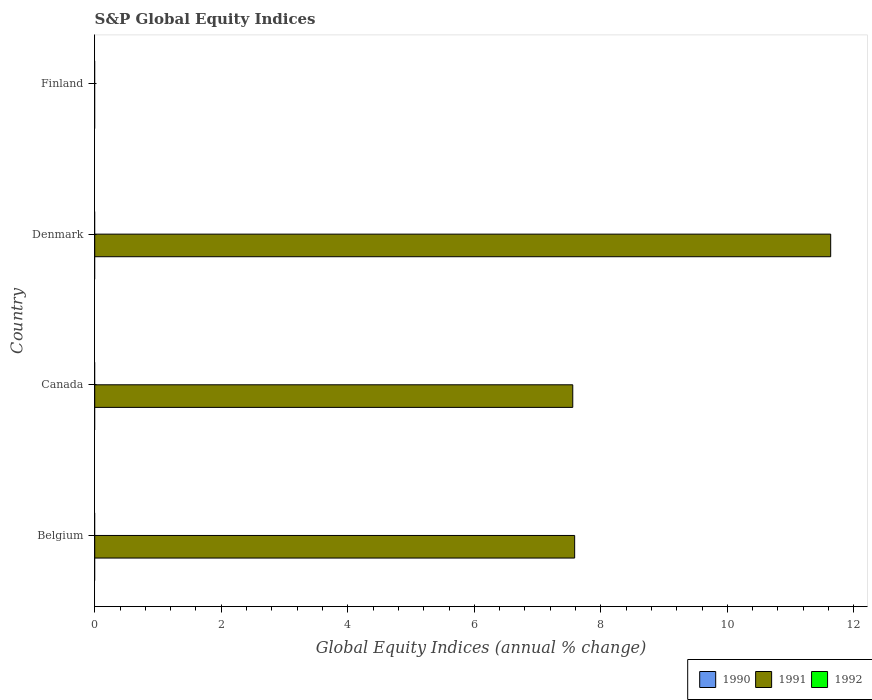How many bars are there on the 2nd tick from the top?
Keep it short and to the point. 1. What is the global equity indices in 1991 in Denmark?
Your response must be concise. 11.63. Across all countries, what is the maximum global equity indices in 1991?
Ensure brevity in your answer.  11.63. Across all countries, what is the minimum global equity indices in 1990?
Provide a short and direct response. 0. In which country was the global equity indices in 1991 maximum?
Provide a short and direct response. Denmark. What is the total global equity indices in 1991 in the graph?
Give a very brief answer. 26.78. What is the average global equity indices in 1992 per country?
Make the answer very short. 0. In how many countries, is the global equity indices in 1991 greater than 8 %?
Your response must be concise. 1. What is the ratio of the global equity indices in 1991 in Canada to that in Denmark?
Give a very brief answer. 0.65. What is the difference between the highest and the second highest global equity indices in 1991?
Offer a terse response. 4.05. What is the difference between the highest and the lowest global equity indices in 1991?
Offer a very short reply. 11.63. Is it the case that in every country, the sum of the global equity indices in 1992 and global equity indices in 1991 is greater than the global equity indices in 1990?
Your answer should be compact. No. How many bars are there?
Provide a succinct answer. 3. How many countries are there in the graph?
Offer a terse response. 4. What is the difference between two consecutive major ticks on the X-axis?
Your answer should be very brief. 2. Does the graph contain any zero values?
Provide a succinct answer. Yes. Does the graph contain grids?
Make the answer very short. No. Where does the legend appear in the graph?
Your response must be concise. Bottom right. How are the legend labels stacked?
Your response must be concise. Horizontal. What is the title of the graph?
Provide a succinct answer. S&P Global Equity Indices. Does "1973" appear as one of the legend labels in the graph?
Your answer should be compact. No. What is the label or title of the X-axis?
Make the answer very short. Global Equity Indices (annual % change). What is the Global Equity Indices (annual % change) in 1990 in Belgium?
Offer a very short reply. 0. What is the Global Equity Indices (annual % change) of 1991 in Belgium?
Provide a short and direct response. 7.59. What is the Global Equity Indices (annual % change) in 1990 in Canada?
Your answer should be compact. 0. What is the Global Equity Indices (annual % change) in 1991 in Canada?
Offer a very short reply. 7.56. What is the Global Equity Indices (annual % change) in 1991 in Denmark?
Your answer should be very brief. 11.63. What is the Global Equity Indices (annual % change) in 1990 in Finland?
Ensure brevity in your answer.  0. Across all countries, what is the maximum Global Equity Indices (annual % change) in 1991?
Provide a short and direct response. 11.63. Across all countries, what is the minimum Global Equity Indices (annual % change) in 1991?
Provide a succinct answer. 0. What is the total Global Equity Indices (annual % change) of 1991 in the graph?
Your response must be concise. 26.78. What is the difference between the Global Equity Indices (annual % change) of 1991 in Belgium and that in Canada?
Provide a succinct answer. 0.03. What is the difference between the Global Equity Indices (annual % change) in 1991 in Belgium and that in Denmark?
Your response must be concise. -4.05. What is the difference between the Global Equity Indices (annual % change) in 1991 in Canada and that in Denmark?
Ensure brevity in your answer.  -4.08. What is the average Global Equity Indices (annual % change) of 1991 per country?
Make the answer very short. 6.69. What is the average Global Equity Indices (annual % change) in 1992 per country?
Your answer should be very brief. 0. What is the ratio of the Global Equity Indices (annual % change) in 1991 in Belgium to that in Denmark?
Your answer should be compact. 0.65. What is the ratio of the Global Equity Indices (annual % change) in 1991 in Canada to that in Denmark?
Offer a terse response. 0.65. What is the difference between the highest and the second highest Global Equity Indices (annual % change) of 1991?
Provide a succinct answer. 4.05. What is the difference between the highest and the lowest Global Equity Indices (annual % change) of 1991?
Offer a very short reply. 11.63. 